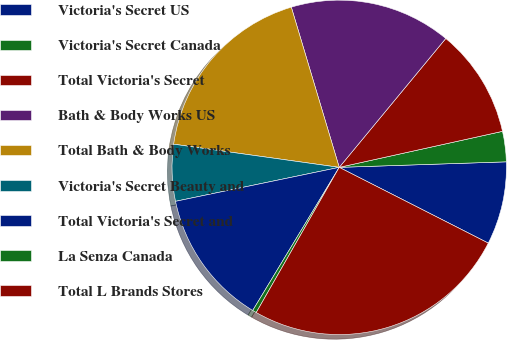Convert chart to OTSL. <chart><loc_0><loc_0><loc_500><loc_500><pie_chart><fcel>Victoria's Secret US<fcel>Victoria's Secret Canada<fcel>Total Victoria's Secret<fcel>Bath & Body Works US<fcel>Total Bath & Body Works<fcel>Victoria's Secret Beauty and<fcel>Total Victoria's Secret and<fcel>La Senza Canada<fcel>Total L Brands Stores<nl><fcel>8.01%<fcel>2.93%<fcel>10.55%<fcel>15.62%<fcel>18.16%<fcel>5.47%<fcel>13.09%<fcel>0.39%<fcel>25.78%<nl></chart> 